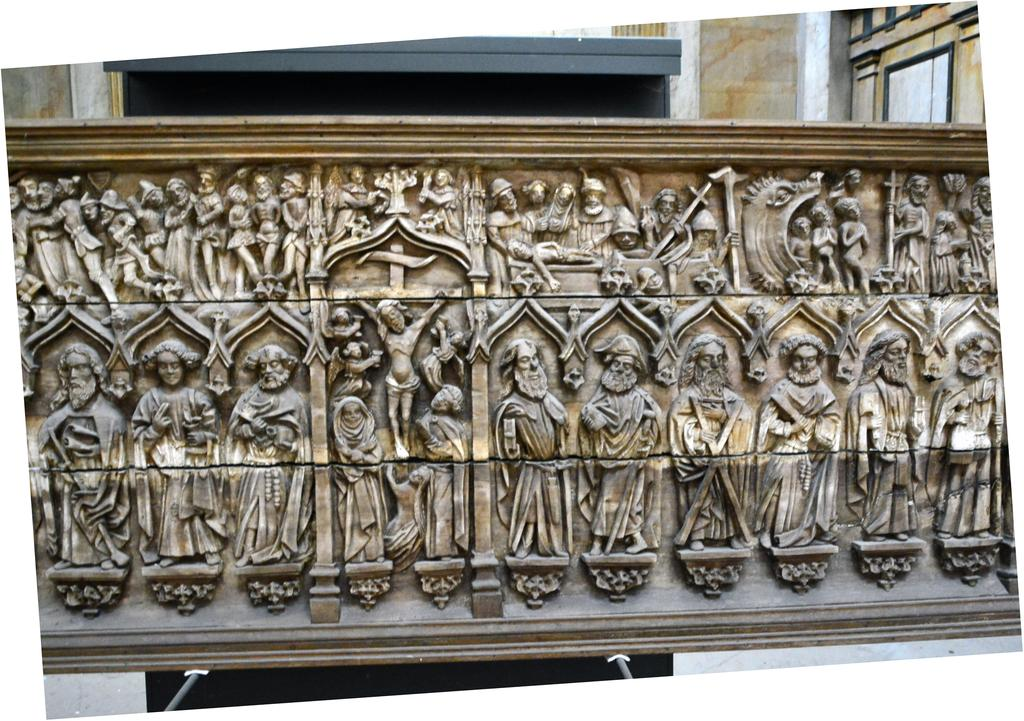What type of artwork is depicted on the wall in the image? There are sculptures of people on a wall in the image. What can be seen in the background of the image? There is a building in the background of the image. Where is the calendar located in the image? There is no calendar present in the image. What type of hospital is shown in the image? There is no hospital depicted in the image; it features sculptures of people on a wall and a building in the background. 